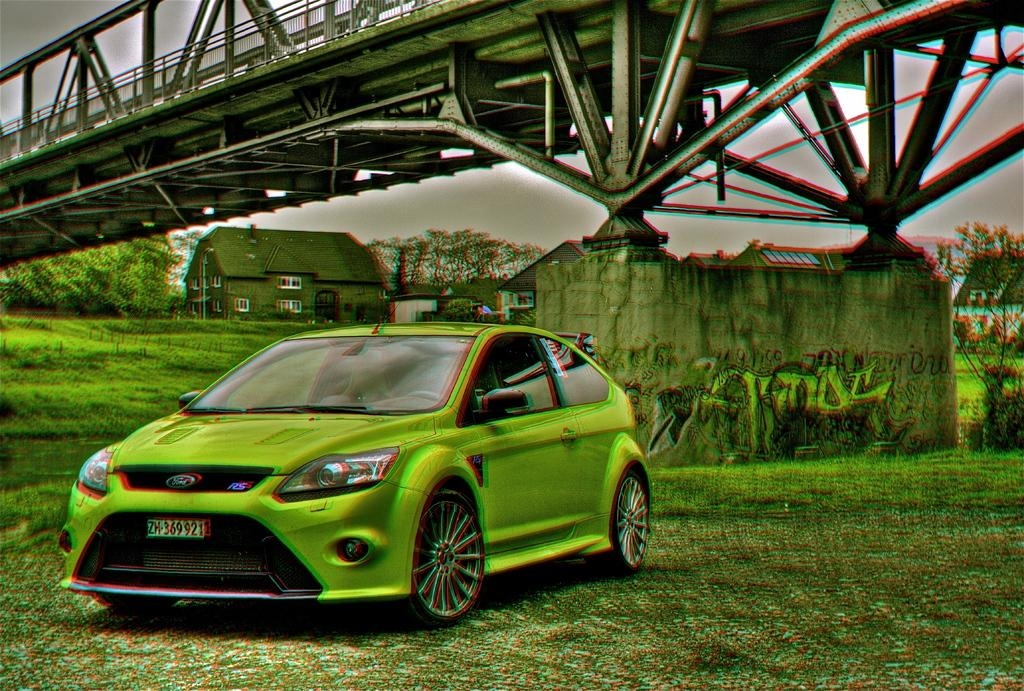What is the main subject of the image? There is a car in the image. Where is the car located? The car is on the ground. What can be seen in the background of the image? There is a bridge, a house, many trees, and the sky visible in the background of the image. How does the car adjust its digestion in the image? Cars do not have digestion, as they are inanimate objects. The question is not applicable to the image. 